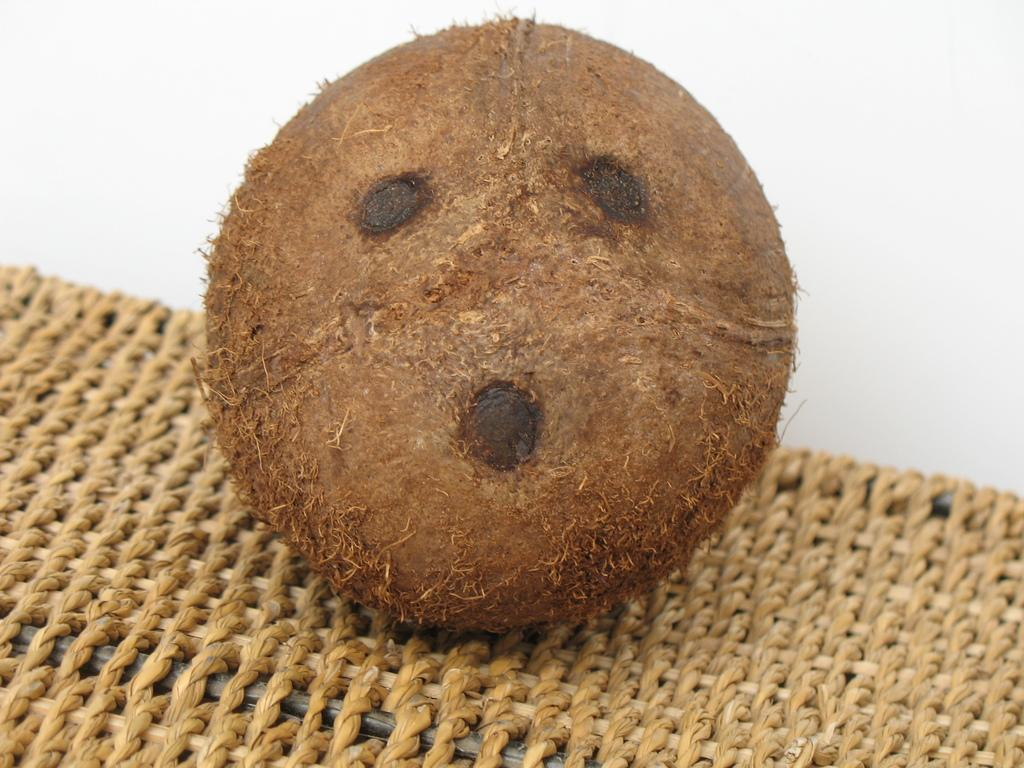What is the main object in the center of the image? There is a coconut in the center of the image. What is located at the bottom of the image? There is a table at the bottom of the image. What can be seen in the background of the image? There is a wall in the background of the image. What direction is the baseball heading in the image? There is no baseball present in the image. 